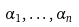<formula> <loc_0><loc_0><loc_500><loc_500>\alpha _ { 1 } , \dots , \alpha _ { n }</formula> 